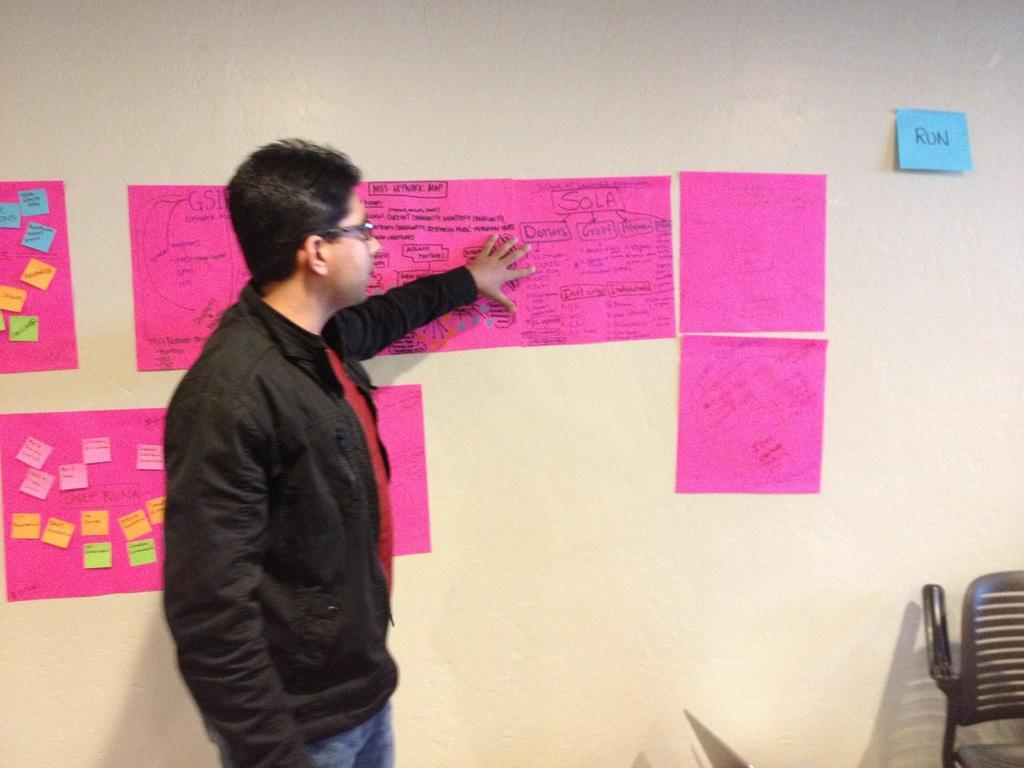What is the main subject of the image? There is a person standing in the center of the image. Can you describe the person's clothing? The person is wearing a black jacket. What object is located on the right side of the image? There is a chair on the right side of the image. What can be seen on the wall behind the person? Charts are attached to the wall behind the person. What type of leaf is falling from the ceiling in the image? There is no leaf falling from the ceiling in the image. What form is the person filling out in the image? There is no form present in the image; the person is simply standing in the center. 